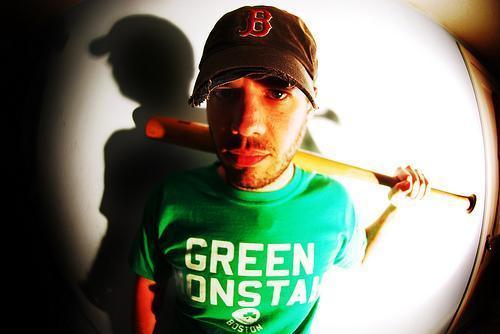How many people are in the image?
Give a very brief answer. 1. 